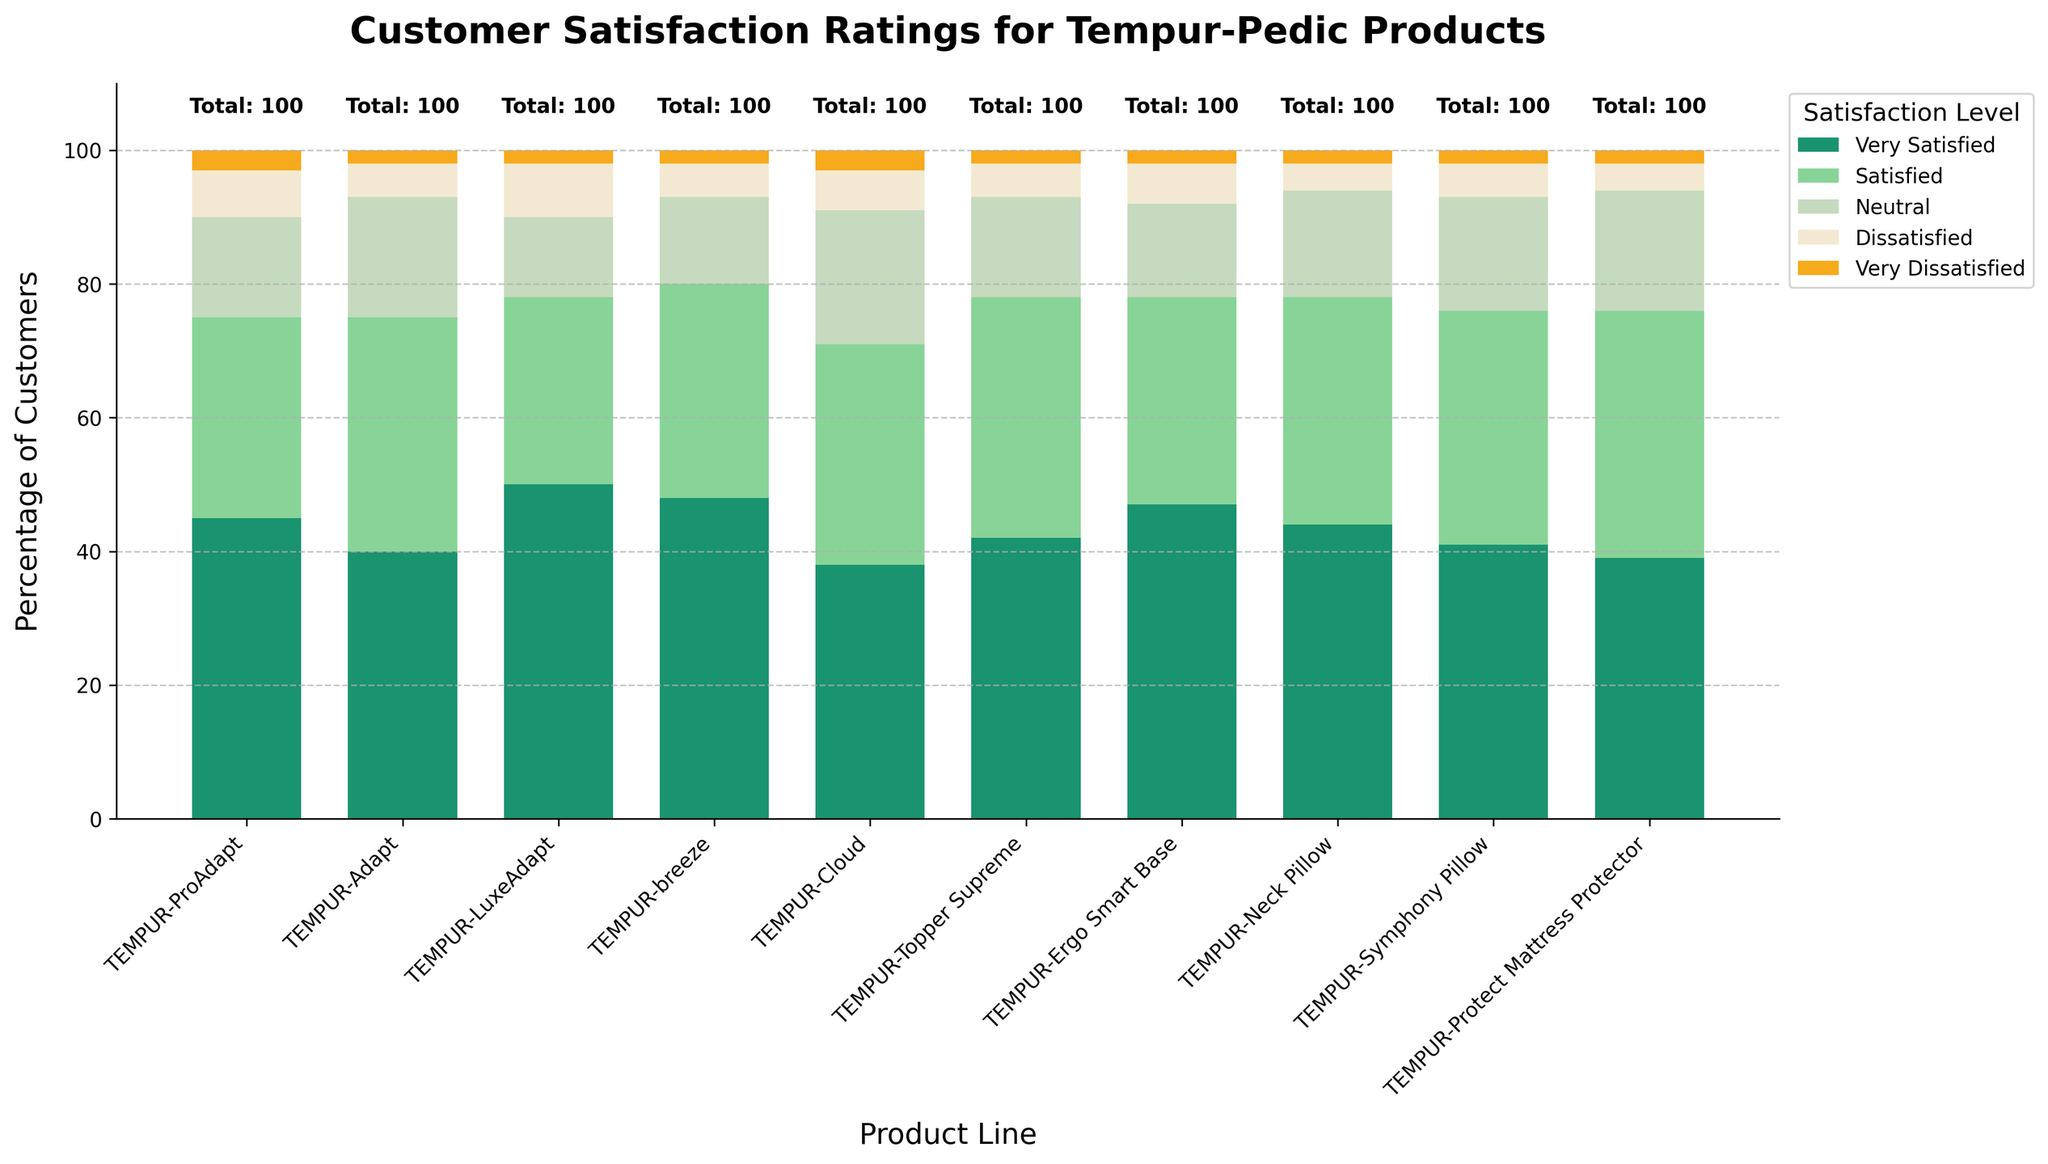Which product line has the highest percentage of very satisfied customers? Look at the bars representing "Very Satisfied" customers and identify which one is the tallest. TEMPUR-LuxeAdapt has the highest bar for "Very Satisfied" customers.
Answer: TEMPUR-LuxeAdapt Which product line has the smallest percentage of neutral customers? Identify which bar stack has the smallest segment for "Neutral" customers. TEMPUR-LuxeAdapt has the lowest value of 12%.
Answer: TEMPUR-LuxeAdapt Compare the total satisfaction (Very Satisfied + Satisfied) between TEMPUR-Topper Supreme and TEMPUR-Cloud. Which one is higher? Sum the values of "Very Satisfied" and "Satisfied" for each of the two product lines and compare them. TEMPUR-Topper Supreme has 42+36=78, while TEMPUR-Cloud has 38+33=71. 78 is greater than 71.
Answer: TEMPUR-Topper Supreme Which product line has the highest overall dissatisfaction (Dissatisfied + Very Dissatisfied)? Add the values of "Dissatisfied" and "Very Dissatisfied" for each product line and identify the highest sum. TEMPUR-LuxeAdapt has the highest sum (8+2=10).
Answer: TEMPUR-LuxeAdapt How many product lines have more than 70% of customers either satisfied or very satisfied? Count the product lines where the sum of "Very Satisfied" and "Satisfied" values exceeds 70%. TEMPUR-ProAdapt, TEMPUR-Adapt, TEMPUR-LuxeAdapt, TEMPUR-breeze, TEMPUR-Topper Supreme, TEMPUR-Ergo Smart Base, and TEMPUR-Neck Pillow are above 70%. There are 7 product lines in total.
Answer: 7 What is the average percentage of dissatisfied customers across all product lines? Add the percentage values of dissatisfied customers across all product lines and divide by the number of product lines. (7+5+8+5+6+5+6+4+5+4) / 10 = 5.5
Answer: 5.5 For TEMPUR-ProAdapt and TEMPUR-Adapt, which category (Very Satisfied, Satisfied, Neutral, Dissatisfied, Very Dissatisfied) shows the biggest difference? Find the differences in each category and identify the category with the highest absolute value. Differences: Very Satisfied: 45-40=5, Satisfied: 30-35=5, Neutral: 15-18=3, Dissatisfied: 7-5=2, Very Dissatisfied: 3-2=1. The biggest differences are in "Very Satisfied" and "Satisfied" with a difference of 5 each.
Answer: Very Satisfied, Satisfied What is the median value of satisfied customers across the product lines? Order the "Satisfied" value counts and find the middle value. Values: 28, 30, 31, 32, 33, 34, 35, 35, 36, 37. The median is (34+35)/2 = 34.5.
Answer: 34.5 Which product line has the second highest total "Very Satisfied" customers? Rank the "Very Satisfied" values and identify the second highest. The highest is TEMPUR-LuxeAdapt (50), and the second highest is TEMPUR-breeze (48).
Answer: TEMPUR-breeze For the TEMPUR-Neck Pillow, what is the sum percentage of all categories except "Very Satisfied"? Add the percentage values of all categories except "Very Satisfied" for TEMPUR-Neck Pillow. Satisfied: 34, Neutral: 16, Dissatisfied: 4, Very Dissatisfied: 2. Sum: 34+16+4+2=56.
Answer: 56 